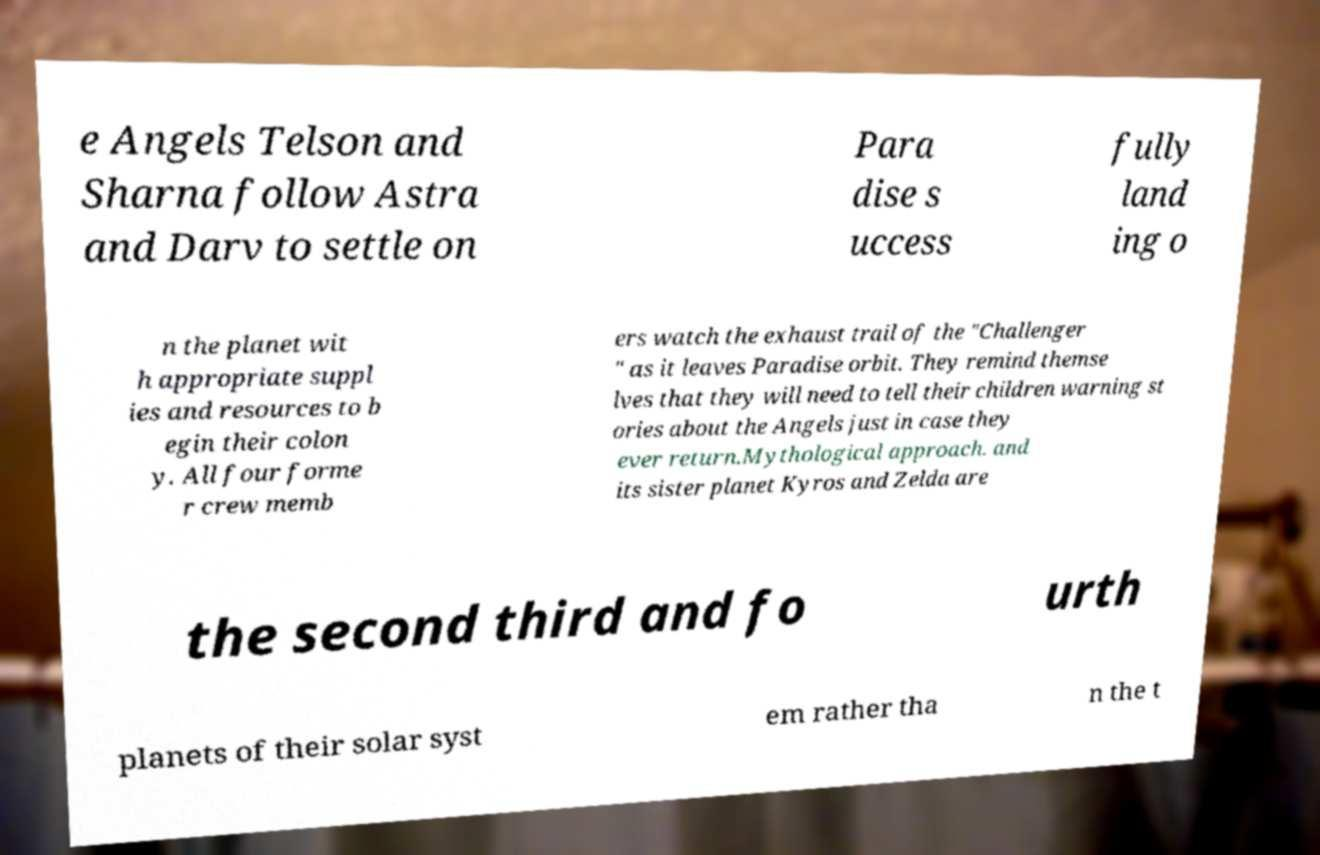There's text embedded in this image that I need extracted. Can you transcribe it verbatim? e Angels Telson and Sharna follow Astra and Darv to settle on Para dise s uccess fully land ing o n the planet wit h appropriate suppl ies and resources to b egin their colon y. All four forme r crew memb ers watch the exhaust trail of the "Challenger " as it leaves Paradise orbit. They remind themse lves that they will need to tell their children warning st ories about the Angels just in case they ever return.Mythological approach. and its sister planet Kyros and Zelda are the second third and fo urth planets of their solar syst em rather tha n the t 